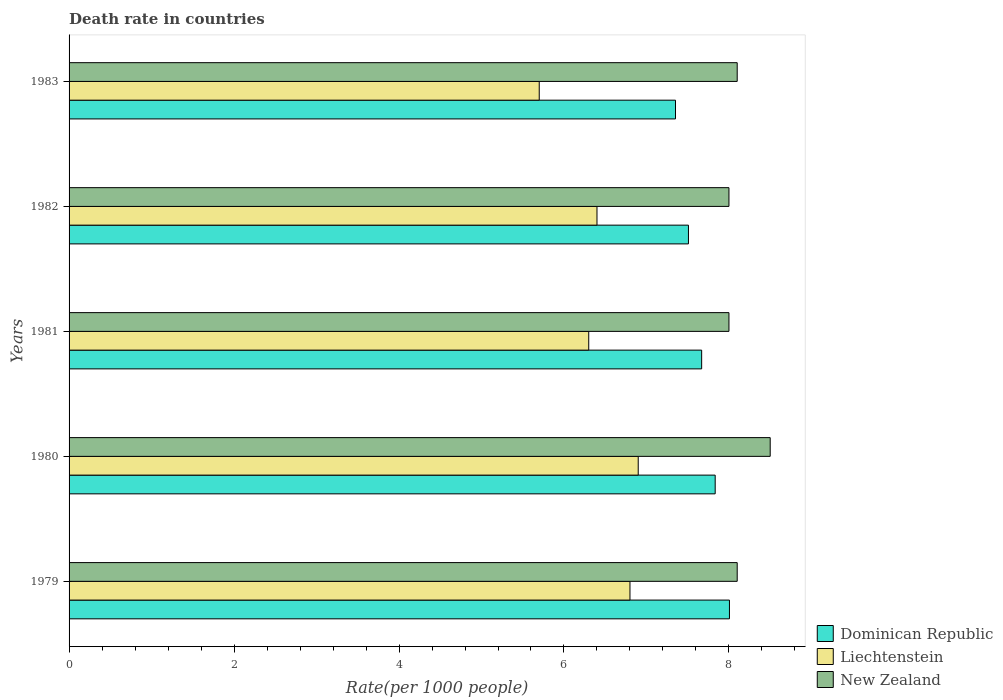How many different coloured bars are there?
Provide a succinct answer. 3. Are the number of bars per tick equal to the number of legend labels?
Your answer should be compact. Yes. Are the number of bars on each tick of the Y-axis equal?
Keep it short and to the point. Yes. How many bars are there on the 5th tick from the top?
Make the answer very short. 3. What is the label of the 2nd group of bars from the top?
Keep it short and to the point. 1982. In how many cases, is the number of bars for a given year not equal to the number of legend labels?
Provide a short and direct response. 0. What is the death rate in Dominican Republic in 1982?
Give a very brief answer. 7.51. Across all years, what is the maximum death rate in Dominican Republic?
Make the answer very short. 8.01. Across all years, what is the minimum death rate in Dominican Republic?
Your response must be concise. 7.35. In which year was the death rate in Liechtenstein maximum?
Make the answer very short. 1980. What is the total death rate in Dominican Republic in the graph?
Ensure brevity in your answer.  38.37. What is the difference between the death rate in Dominican Republic in 1982 and that in 1983?
Make the answer very short. 0.16. What is the difference between the death rate in New Zealand in 1983 and the death rate in Dominican Republic in 1982?
Your answer should be compact. 0.59. What is the average death rate in Dominican Republic per year?
Provide a succinct answer. 7.67. In the year 1980, what is the difference between the death rate in New Zealand and death rate in Dominican Republic?
Offer a very short reply. 0.67. What is the ratio of the death rate in Liechtenstein in 1980 to that in 1981?
Give a very brief answer. 1.1. Is the death rate in Liechtenstein in 1980 less than that in 1981?
Give a very brief answer. No. Is the difference between the death rate in New Zealand in 1979 and 1982 greater than the difference between the death rate in Dominican Republic in 1979 and 1982?
Keep it short and to the point. No. What is the difference between the highest and the second highest death rate in Liechtenstein?
Your answer should be compact. 0.1. In how many years, is the death rate in New Zealand greater than the average death rate in New Zealand taken over all years?
Your response must be concise. 1. What does the 1st bar from the top in 1981 represents?
Provide a succinct answer. New Zealand. What does the 1st bar from the bottom in 1983 represents?
Offer a terse response. Dominican Republic. How many bars are there?
Give a very brief answer. 15. What is the difference between two consecutive major ticks on the X-axis?
Offer a very short reply. 2. Are the values on the major ticks of X-axis written in scientific E-notation?
Offer a terse response. No. Does the graph contain any zero values?
Provide a succinct answer. No. What is the title of the graph?
Ensure brevity in your answer.  Death rate in countries. Does "Hong Kong" appear as one of the legend labels in the graph?
Your answer should be very brief. No. What is the label or title of the X-axis?
Your answer should be compact. Rate(per 1000 people). What is the label or title of the Y-axis?
Your response must be concise. Years. What is the Rate(per 1000 people) in Dominican Republic in 1979?
Offer a terse response. 8.01. What is the Rate(per 1000 people) of Dominican Republic in 1980?
Provide a short and direct response. 7.83. What is the Rate(per 1000 people) in Liechtenstein in 1980?
Keep it short and to the point. 6.9. What is the Rate(per 1000 people) of New Zealand in 1980?
Keep it short and to the point. 8.5. What is the Rate(per 1000 people) in Dominican Republic in 1981?
Give a very brief answer. 7.67. What is the Rate(per 1000 people) of Liechtenstein in 1981?
Provide a short and direct response. 6.3. What is the Rate(per 1000 people) in New Zealand in 1981?
Offer a terse response. 8. What is the Rate(per 1000 people) of Dominican Republic in 1982?
Your response must be concise. 7.51. What is the Rate(per 1000 people) of Dominican Republic in 1983?
Provide a succinct answer. 7.35. Across all years, what is the maximum Rate(per 1000 people) of Dominican Republic?
Give a very brief answer. 8.01. Across all years, what is the minimum Rate(per 1000 people) in Dominican Republic?
Your answer should be compact. 7.35. Across all years, what is the minimum Rate(per 1000 people) of New Zealand?
Ensure brevity in your answer.  8. What is the total Rate(per 1000 people) of Dominican Republic in the graph?
Provide a succinct answer. 38.37. What is the total Rate(per 1000 people) in Liechtenstein in the graph?
Provide a succinct answer. 32.1. What is the total Rate(per 1000 people) in New Zealand in the graph?
Your answer should be compact. 40.7. What is the difference between the Rate(per 1000 people) of Dominican Republic in 1979 and that in 1980?
Ensure brevity in your answer.  0.17. What is the difference between the Rate(per 1000 people) of Liechtenstein in 1979 and that in 1980?
Provide a succinct answer. -0.1. What is the difference between the Rate(per 1000 people) of Dominican Republic in 1979 and that in 1981?
Your answer should be very brief. 0.34. What is the difference between the Rate(per 1000 people) of Liechtenstein in 1979 and that in 1981?
Make the answer very short. 0.5. What is the difference between the Rate(per 1000 people) in New Zealand in 1979 and that in 1981?
Your answer should be compact. 0.1. What is the difference between the Rate(per 1000 people) in Dominican Republic in 1979 and that in 1982?
Provide a short and direct response. 0.5. What is the difference between the Rate(per 1000 people) in New Zealand in 1979 and that in 1982?
Give a very brief answer. 0.1. What is the difference between the Rate(per 1000 people) of Dominican Republic in 1979 and that in 1983?
Your answer should be compact. 0.65. What is the difference between the Rate(per 1000 people) of Dominican Republic in 1980 and that in 1981?
Offer a terse response. 0.16. What is the difference between the Rate(per 1000 people) of Dominican Republic in 1980 and that in 1982?
Your response must be concise. 0.32. What is the difference between the Rate(per 1000 people) of Liechtenstein in 1980 and that in 1982?
Make the answer very short. 0.5. What is the difference between the Rate(per 1000 people) in New Zealand in 1980 and that in 1982?
Provide a short and direct response. 0.5. What is the difference between the Rate(per 1000 people) in Dominican Republic in 1980 and that in 1983?
Give a very brief answer. 0.48. What is the difference between the Rate(per 1000 people) of New Zealand in 1980 and that in 1983?
Your answer should be very brief. 0.4. What is the difference between the Rate(per 1000 people) in Dominican Republic in 1981 and that in 1982?
Offer a very short reply. 0.16. What is the difference between the Rate(per 1000 people) of New Zealand in 1981 and that in 1982?
Offer a very short reply. 0. What is the difference between the Rate(per 1000 people) in Dominican Republic in 1981 and that in 1983?
Your response must be concise. 0.32. What is the difference between the Rate(per 1000 people) in Liechtenstein in 1981 and that in 1983?
Make the answer very short. 0.6. What is the difference between the Rate(per 1000 people) in New Zealand in 1981 and that in 1983?
Provide a short and direct response. -0.1. What is the difference between the Rate(per 1000 people) of Dominican Republic in 1982 and that in 1983?
Provide a succinct answer. 0.16. What is the difference between the Rate(per 1000 people) in Dominican Republic in 1979 and the Rate(per 1000 people) in Liechtenstein in 1980?
Your response must be concise. 1.11. What is the difference between the Rate(per 1000 people) of Dominican Republic in 1979 and the Rate(per 1000 people) of New Zealand in 1980?
Your response must be concise. -0.49. What is the difference between the Rate(per 1000 people) of Dominican Republic in 1979 and the Rate(per 1000 people) of Liechtenstein in 1981?
Provide a short and direct response. 1.71. What is the difference between the Rate(per 1000 people) of Dominican Republic in 1979 and the Rate(per 1000 people) of New Zealand in 1981?
Provide a succinct answer. 0.01. What is the difference between the Rate(per 1000 people) in Dominican Republic in 1979 and the Rate(per 1000 people) in Liechtenstein in 1982?
Keep it short and to the point. 1.61. What is the difference between the Rate(per 1000 people) in Dominican Republic in 1979 and the Rate(per 1000 people) in New Zealand in 1982?
Make the answer very short. 0.01. What is the difference between the Rate(per 1000 people) in Dominican Republic in 1979 and the Rate(per 1000 people) in Liechtenstein in 1983?
Provide a succinct answer. 2.31. What is the difference between the Rate(per 1000 people) in Dominican Republic in 1979 and the Rate(per 1000 people) in New Zealand in 1983?
Offer a very short reply. -0.09. What is the difference between the Rate(per 1000 people) in Liechtenstein in 1979 and the Rate(per 1000 people) in New Zealand in 1983?
Ensure brevity in your answer.  -1.3. What is the difference between the Rate(per 1000 people) of Dominican Republic in 1980 and the Rate(per 1000 people) of Liechtenstein in 1981?
Your response must be concise. 1.53. What is the difference between the Rate(per 1000 people) of Dominican Republic in 1980 and the Rate(per 1000 people) of New Zealand in 1981?
Your answer should be compact. -0.17. What is the difference between the Rate(per 1000 people) of Dominican Republic in 1980 and the Rate(per 1000 people) of Liechtenstein in 1982?
Keep it short and to the point. 1.43. What is the difference between the Rate(per 1000 people) in Dominican Republic in 1980 and the Rate(per 1000 people) in New Zealand in 1982?
Keep it short and to the point. -0.17. What is the difference between the Rate(per 1000 people) in Dominican Republic in 1980 and the Rate(per 1000 people) in Liechtenstein in 1983?
Make the answer very short. 2.13. What is the difference between the Rate(per 1000 people) in Dominican Republic in 1980 and the Rate(per 1000 people) in New Zealand in 1983?
Your answer should be compact. -0.27. What is the difference between the Rate(per 1000 people) in Liechtenstein in 1980 and the Rate(per 1000 people) in New Zealand in 1983?
Offer a very short reply. -1.2. What is the difference between the Rate(per 1000 people) of Dominican Republic in 1981 and the Rate(per 1000 people) of Liechtenstein in 1982?
Provide a short and direct response. 1.27. What is the difference between the Rate(per 1000 people) in Dominican Republic in 1981 and the Rate(per 1000 people) in New Zealand in 1982?
Give a very brief answer. -0.33. What is the difference between the Rate(per 1000 people) in Liechtenstein in 1981 and the Rate(per 1000 people) in New Zealand in 1982?
Offer a very short reply. -1.7. What is the difference between the Rate(per 1000 people) of Dominican Republic in 1981 and the Rate(per 1000 people) of Liechtenstein in 1983?
Make the answer very short. 1.97. What is the difference between the Rate(per 1000 people) in Dominican Republic in 1981 and the Rate(per 1000 people) in New Zealand in 1983?
Your answer should be very brief. -0.43. What is the difference between the Rate(per 1000 people) in Dominican Republic in 1982 and the Rate(per 1000 people) in Liechtenstein in 1983?
Provide a succinct answer. 1.81. What is the difference between the Rate(per 1000 people) of Dominican Republic in 1982 and the Rate(per 1000 people) of New Zealand in 1983?
Make the answer very short. -0.59. What is the average Rate(per 1000 people) of Dominican Republic per year?
Keep it short and to the point. 7.67. What is the average Rate(per 1000 people) in Liechtenstein per year?
Offer a very short reply. 6.42. What is the average Rate(per 1000 people) in New Zealand per year?
Give a very brief answer. 8.14. In the year 1979, what is the difference between the Rate(per 1000 people) in Dominican Republic and Rate(per 1000 people) in Liechtenstein?
Give a very brief answer. 1.21. In the year 1979, what is the difference between the Rate(per 1000 people) in Dominican Republic and Rate(per 1000 people) in New Zealand?
Make the answer very short. -0.09. In the year 1979, what is the difference between the Rate(per 1000 people) in Liechtenstein and Rate(per 1000 people) in New Zealand?
Offer a very short reply. -1.3. In the year 1980, what is the difference between the Rate(per 1000 people) in Dominican Republic and Rate(per 1000 people) in Liechtenstein?
Make the answer very short. 0.93. In the year 1980, what is the difference between the Rate(per 1000 people) of Dominican Republic and Rate(per 1000 people) of New Zealand?
Keep it short and to the point. -0.67. In the year 1980, what is the difference between the Rate(per 1000 people) of Liechtenstein and Rate(per 1000 people) of New Zealand?
Your answer should be compact. -1.6. In the year 1981, what is the difference between the Rate(per 1000 people) in Dominican Republic and Rate(per 1000 people) in Liechtenstein?
Your answer should be compact. 1.37. In the year 1981, what is the difference between the Rate(per 1000 people) of Dominican Republic and Rate(per 1000 people) of New Zealand?
Offer a terse response. -0.33. In the year 1981, what is the difference between the Rate(per 1000 people) of Liechtenstein and Rate(per 1000 people) of New Zealand?
Keep it short and to the point. -1.7. In the year 1982, what is the difference between the Rate(per 1000 people) in Dominican Republic and Rate(per 1000 people) in Liechtenstein?
Give a very brief answer. 1.11. In the year 1982, what is the difference between the Rate(per 1000 people) of Dominican Republic and Rate(per 1000 people) of New Zealand?
Your response must be concise. -0.49. In the year 1982, what is the difference between the Rate(per 1000 people) in Liechtenstein and Rate(per 1000 people) in New Zealand?
Give a very brief answer. -1.6. In the year 1983, what is the difference between the Rate(per 1000 people) in Dominican Republic and Rate(per 1000 people) in Liechtenstein?
Offer a terse response. 1.65. In the year 1983, what is the difference between the Rate(per 1000 people) of Dominican Republic and Rate(per 1000 people) of New Zealand?
Your response must be concise. -0.75. What is the ratio of the Rate(per 1000 people) in Dominican Republic in 1979 to that in 1980?
Make the answer very short. 1.02. What is the ratio of the Rate(per 1000 people) in Liechtenstein in 1979 to that in 1980?
Keep it short and to the point. 0.99. What is the ratio of the Rate(per 1000 people) of New Zealand in 1979 to that in 1980?
Make the answer very short. 0.95. What is the ratio of the Rate(per 1000 people) of Dominican Republic in 1979 to that in 1981?
Give a very brief answer. 1.04. What is the ratio of the Rate(per 1000 people) of Liechtenstein in 1979 to that in 1981?
Provide a succinct answer. 1.08. What is the ratio of the Rate(per 1000 people) in New Zealand in 1979 to that in 1981?
Your answer should be compact. 1.01. What is the ratio of the Rate(per 1000 people) in Dominican Republic in 1979 to that in 1982?
Provide a short and direct response. 1.07. What is the ratio of the Rate(per 1000 people) of Liechtenstein in 1979 to that in 1982?
Give a very brief answer. 1.06. What is the ratio of the Rate(per 1000 people) in New Zealand in 1979 to that in 1982?
Provide a short and direct response. 1.01. What is the ratio of the Rate(per 1000 people) in Dominican Republic in 1979 to that in 1983?
Your response must be concise. 1.09. What is the ratio of the Rate(per 1000 people) of Liechtenstein in 1979 to that in 1983?
Your answer should be very brief. 1.19. What is the ratio of the Rate(per 1000 people) in New Zealand in 1979 to that in 1983?
Make the answer very short. 1. What is the ratio of the Rate(per 1000 people) of Dominican Republic in 1980 to that in 1981?
Keep it short and to the point. 1.02. What is the ratio of the Rate(per 1000 people) in Liechtenstein in 1980 to that in 1981?
Provide a succinct answer. 1.1. What is the ratio of the Rate(per 1000 people) in Dominican Republic in 1980 to that in 1982?
Your response must be concise. 1.04. What is the ratio of the Rate(per 1000 people) in Liechtenstein in 1980 to that in 1982?
Give a very brief answer. 1.08. What is the ratio of the Rate(per 1000 people) in Dominican Republic in 1980 to that in 1983?
Keep it short and to the point. 1.07. What is the ratio of the Rate(per 1000 people) of Liechtenstein in 1980 to that in 1983?
Your answer should be very brief. 1.21. What is the ratio of the Rate(per 1000 people) of New Zealand in 1980 to that in 1983?
Your answer should be very brief. 1.05. What is the ratio of the Rate(per 1000 people) of Dominican Republic in 1981 to that in 1982?
Your answer should be compact. 1.02. What is the ratio of the Rate(per 1000 people) of Liechtenstein in 1981 to that in 1982?
Your answer should be compact. 0.98. What is the ratio of the Rate(per 1000 people) of Dominican Republic in 1981 to that in 1983?
Ensure brevity in your answer.  1.04. What is the ratio of the Rate(per 1000 people) in Liechtenstein in 1981 to that in 1983?
Your answer should be very brief. 1.11. What is the ratio of the Rate(per 1000 people) in Dominican Republic in 1982 to that in 1983?
Your answer should be compact. 1.02. What is the ratio of the Rate(per 1000 people) of Liechtenstein in 1982 to that in 1983?
Your answer should be very brief. 1.12. What is the difference between the highest and the second highest Rate(per 1000 people) of Dominican Republic?
Make the answer very short. 0.17. What is the difference between the highest and the lowest Rate(per 1000 people) of Dominican Republic?
Ensure brevity in your answer.  0.65. What is the difference between the highest and the lowest Rate(per 1000 people) in Liechtenstein?
Your answer should be very brief. 1.2. 